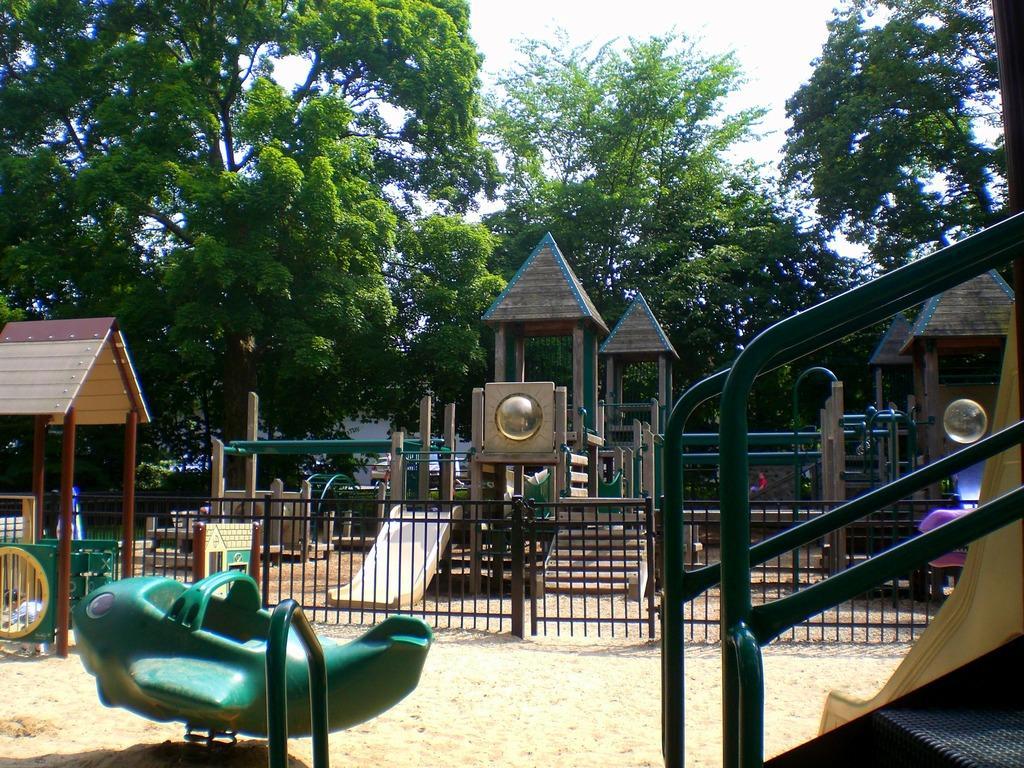Describe this image in one or two sentences. In this image there are trees, and there are few equipment for the kids like sliders etc. 